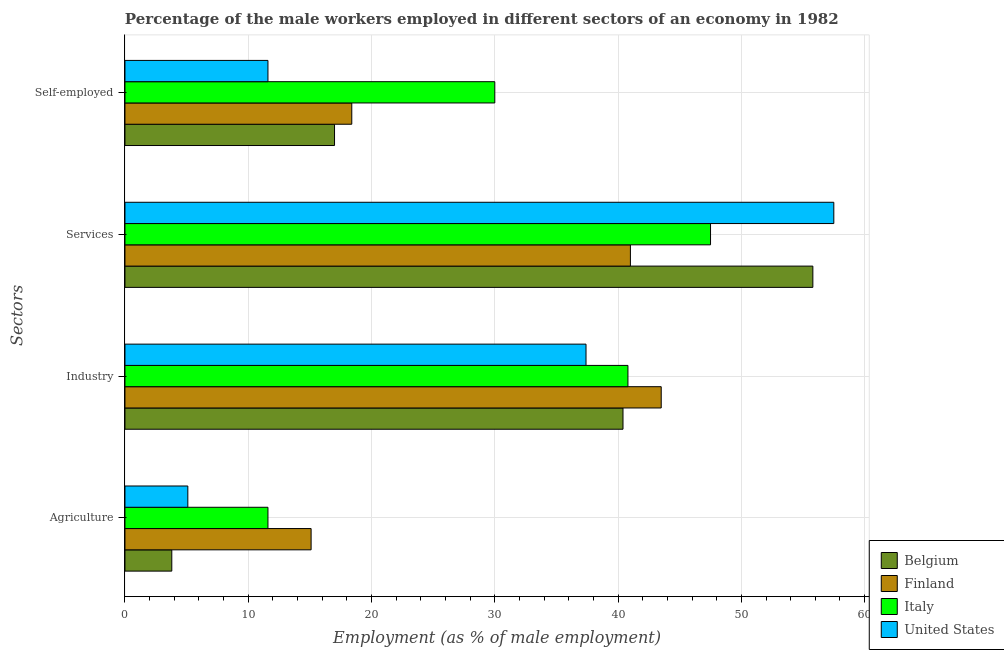How many groups of bars are there?
Offer a terse response. 4. Are the number of bars per tick equal to the number of legend labels?
Offer a terse response. Yes. Are the number of bars on each tick of the Y-axis equal?
Keep it short and to the point. Yes. What is the label of the 4th group of bars from the top?
Provide a short and direct response. Agriculture. What is the percentage of male workers in services in Italy?
Offer a terse response. 47.5. Across all countries, what is the maximum percentage of male workers in agriculture?
Offer a very short reply. 15.1. Across all countries, what is the minimum percentage of male workers in industry?
Your answer should be very brief. 37.4. What is the total percentage of self employed male workers in the graph?
Your answer should be very brief. 77. What is the difference between the percentage of male workers in industry in Finland and that in Italy?
Your answer should be very brief. 2.7. What is the difference between the percentage of male workers in agriculture in United States and the percentage of male workers in services in Finland?
Ensure brevity in your answer.  -35.9. What is the average percentage of male workers in services per country?
Your answer should be compact. 50.45. What is the difference between the percentage of male workers in services and percentage of male workers in agriculture in Finland?
Offer a terse response. 25.9. What is the ratio of the percentage of male workers in agriculture in Belgium to that in Finland?
Offer a terse response. 0.25. Is the difference between the percentage of male workers in agriculture in Finland and United States greater than the difference between the percentage of male workers in services in Finland and United States?
Your answer should be compact. Yes. What is the difference between the highest and the second highest percentage of male workers in industry?
Offer a very short reply. 2.7. What is the difference between the highest and the lowest percentage of male workers in agriculture?
Provide a succinct answer. 11.3. In how many countries, is the percentage of male workers in services greater than the average percentage of male workers in services taken over all countries?
Your answer should be compact. 2. Is the sum of the percentage of male workers in agriculture in Belgium and Finland greater than the maximum percentage of male workers in industry across all countries?
Ensure brevity in your answer.  No. Is it the case that in every country, the sum of the percentage of male workers in agriculture and percentage of male workers in services is greater than the sum of percentage of self employed male workers and percentage of male workers in industry?
Keep it short and to the point. No. Is it the case that in every country, the sum of the percentage of male workers in agriculture and percentage of male workers in industry is greater than the percentage of male workers in services?
Provide a short and direct response. No. How many bars are there?
Offer a very short reply. 16. How many legend labels are there?
Make the answer very short. 4. What is the title of the graph?
Keep it short and to the point. Percentage of the male workers employed in different sectors of an economy in 1982. Does "Kazakhstan" appear as one of the legend labels in the graph?
Your answer should be very brief. No. What is the label or title of the X-axis?
Give a very brief answer. Employment (as % of male employment). What is the label or title of the Y-axis?
Give a very brief answer. Sectors. What is the Employment (as % of male employment) of Belgium in Agriculture?
Make the answer very short. 3.8. What is the Employment (as % of male employment) of Finland in Agriculture?
Your response must be concise. 15.1. What is the Employment (as % of male employment) in Italy in Agriculture?
Provide a short and direct response. 11.6. What is the Employment (as % of male employment) of United States in Agriculture?
Ensure brevity in your answer.  5.1. What is the Employment (as % of male employment) in Belgium in Industry?
Your answer should be very brief. 40.4. What is the Employment (as % of male employment) of Finland in Industry?
Provide a short and direct response. 43.5. What is the Employment (as % of male employment) of Italy in Industry?
Your answer should be very brief. 40.8. What is the Employment (as % of male employment) in United States in Industry?
Give a very brief answer. 37.4. What is the Employment (as % of male employment) in Belgium in Services?
Give a very brief answer. 55.8. What is the Employment (as % of male employment) in Italy in Services?
Ensure brevity in your answer.  47.5. What is the Employment (as % of male employment) in United States in Services?
Keep it short and to the point. 57.5. What is the Employment (as % of male employment) of Belgium in Self-employed?
Your response must be concise. 17. What is the Employment (as % of male employment) of Finland in Self-employed?
Your response must be concise. 18.4. What is the Employment (as % of male employment) in Italy in Self-employed?
Provide a short and direct response. 30. What is the Employment (as % of male employment) of United States in Self-employed?
Offer a terse response. 11.6. Across all Sectors, what is the maximum Employment (as % of male employment) of Belgium?
Provide a short and direct response. 55.8. Across all Sectors, what is the maximum Employment (as % of male employment) of Finland?
Give a very brief answer. 43.5. Across all Sectors, what is the maximum Employment (as % of male employment) of Italy?
Give a very brief answer. 47.5. Across all Sectors, what is the maximum Employment (as % of male employment) in United States?
Your answer should be very brief. 57.5. Across all Sectors, what is the minimum Employment (as % of male employment) of Belgium?
Your answer should be compact. 3.8. Across all Sectors, what is the minimum Employment (as % of male employment) of Finland?
Give a very brief answer. 15.1. Across all Sectors, what is the minimum Employment (as % of male employment) of Italy?
Keep it short and to the point. 11.6. Across all Sectors, what is the minimum Employment (as % of male employment) in United States?
Your answer should be very brief. 5.1. What is the total Employment (as % of male employment) of Belgium in the graph?
Provide a succinct answer. 117. What is the total Employment (as % of male employment) in Finland in the graph?
Your answer should be very brief. 118. What is the total Employment (as % of male employment) in Italy in the graph?
Your response must be concise. 129.9. What is the total Employment (as % of male employment) of United States in the graph?
Offer a terse response. 111.6. What is the difference between the Employment (as % of male employment) of Belgium in Agriculture and that in Industry?
Provide a short and direct response. -36.6. What is the difference between the Employment (as % of male employment) of Finland in Agriculture and that in Industry?
Provide a succinct answer. -28.4. What is the difference between the Employment (as % of male employment) of Italy in Agriculture and that in Industry?
Provide a succinct answer. -29.2. What is the difference between the Employment (as % of male employment) of United States in Agriculture and that in Industry?
Give a very brief answer. -32.3. What is the difference between the Employment (as % of male employment) in Belgium in Agriculture and that in Services?
Give a very brief answer. -52. What is the difference between the Employment (as % of male employment) in Finland in Agriculture and that in Services?
Your answer should be compact. -25.9. What is the difference between the Employment (as % of male employment) of Italy in Agriculture and that in Services?
Provide a succinct answer. -35.9. What is the difference between the Employment (as % of male employment) in United States in Agriculture and that in Services?
Make the answer very short. -52.4. What is the difference between the Employment (as % of male employment) of Belgium in Agriculture and that in Self-employed?
Offer a terse response. -13.2. What is the difference between the Employment (as % of male employment) of Italy in Agriculture and that in Self-employed?
Your answer should be compact. -18.4. What is the difference between the Employment (as % of male employment) in Belgium in Industry and that in Services?
Make the answer very short. -15.4. What is the difference between the Employment (as % of male employment) of United States in Industry and that in Services?
Provide a succinct answer. -20.1. What is the difference between the Employment (as % of male employment) in Belgium in Industry and that in Self-employed?
Your answer should be compact. 23.4. What is the difference between the Employment (as % of male employment) in Finland in Industry and that in Self-employed?
Offer a very short reply. 25.1. What is the difference between the Employment (as % of male employment) of Italy in Industry and that in Self-employed?
Offer a very short reply. 10.8. What is the difference between the Employment (as % of male employment) of United States in Industry and that in Self-employed?
Your answer should be compact. 25.8. What is the difference between the Employment (as % of male employment) of Belgium in Services and that in Self-employed?
Your response must be concise. 38.8. What is the difference between the Employment (as % of male employment) of Finland in Services and that in Self-employed?
Give a very brief answer. 22.6. What is the difference between the Employment (as % of male employment) of United States in Services and that in Self-employed?
Your answer should be compact. 45.9. What is the difference between the Employment (as % of male employment) of Belgium in Agriculture and the Employment (as % of male employment) of Finland in Industry?
Give a very brief answer. -39.7. What is the difference between the Employment (as % of male employment) of Belgium in Agriculture and the Employment (as % of male employment) of Italy in Industry?
Keep it short and to the point. -37. What is the difference between the Employment (as % of male employment) in Belgium in Agriculture and the Employment (as % of male employment) in United States in Industry?
Keep it short and to the point. -33.6. What is the difference between the Employment (as % of male employment) of Finland in Agriculture and the Employment (as % of male employment) of Italy in Industry?
Offer a terse response. -25.7. What is the difference between the Employment (as % of male employment) of Finland in Agriculture and the Employment (as % of male employment) of United States in Industry?
Your answer should be compact. -22.3. What is the difference between the Employment (as % of male employment) of Italy in Agriculture and the Employment (as % of male employment) of United States in Industry?
Your response must be concise. -25.8. What is the difference between the Employment (as % of male employment) of Belgium in Agriculture and the Employment (as % of male employment) of Finland in Services?
Offer a terse response. -37.2. What is the difference between the Employment (as % of male employment) of Belgium in Agriculture and the Employment (as % of male employment) of Italy in Services?
Offer a terse response. -43.7. What is the difference between the Employment (as % of male employment) in Belgium in Agriculture and the Employment (as % of male employment) in United States in Services?
Give a very brief answer. -53.7. What is the difference between the Employment (as % of male employment) in Finland in Agriculture and the Employment (as % of male employment) in Italy in Services?
Provide a short and direct response. -32.4. What is the difference between the Employment (as % of male employment) in Finland in Agriculture and the Employment (as % of male employment) in United States in Services?
Your answer should be very brief. -42.4. What is the difference between the Employment (as % of male employment) in Italy in Agriculture and the Employment (as % of male employment) in United States in Services?
Ensure brevity in your answer.  -45.9. What is the difference between the Employment (as % of male employment) in Belgium in Agriculture and the Employment (as % of male employment) in Finland in Self-employed?
Offer a very short reply. -14.6. What is the difference between the Employment (as % of male employment) in Belgium in Agriculture and the Employment (as % of male employment) in Italy in Self-employed?
Your response must be concise. -26.2. What is the difference between the Employment (as % of male employment) in Belgium in Agriculture and the Employment (as % of male employment) in United States in Self-employed?
Your answer should be very brief. -7.8. What is the difference between the Employment (as % of male employment) of Finland in Agriculture and the Employment (as % of male employment) of Italy in Self-employed?
Give a very brief answer. -14.9. What is the difference between the Employment (as % of male employment) of Finland in Agriculture and the Employment (as % of male employment) of United States in Self-employed?
Give a very brief answer. 3.5. What is the difference between the Employment (as % of male employment) of Belgium in Industry and the Employment (as % of male employment) of Italy in Services?
Provide a short and direct response. -7.1. What is the difference between the Employment (as % of male employment) of Belgium in Industry and the Employment (as % of male employment) of United States in Services?
Offer a very short reply. -17.1. What is the difference between the Employment (as % of male employment) in Italy in Industry and the Employment (as % of male employment) in United States in Services?
Your answer should be compact. -16.7. What is the difference between the Employment (as % of male employment) of Belgium in Industry and the Employment (as % of male employment) of Finland in Self-employed?
Your response must be concise. 22. What is the difference between the Employment (as % of male employment) of Belgium in Industry and the Employment (as % of male employment) of Italy in Self-employed?
Your response must be concise. 10.4. What is the difference between the Employment (as % of male employment) in Belgium in Industry and the Employment (as % of male employment) in United States in Self-employed?
Your response must be concise. 28.8. What is the difference between the Employment (as % of male employment) of Finland in Industry and the Employment (as % of male employment) of United States in Self-employed?
Keep it short and to the point. 31.9. What is the difference between the Employment (as % of male employment) of Italy in Industry and the Employment (as % of male employment) of United States in Self-employed?
Your answer should be compact. 29.2. What is the difference between the Employment (as % of male employment) of Belgium in Services and the Employment (as % of male employment) of Finland in Self-employed?
Give a very brief answer. 37.4. What is the difference between the Employment (as % of male employment) in Belgium in Services and the Employment (as % of male employment) in Italy in Self-employed?
Offer a very short reply. 25.8. What is the difference between the Employment (as % of male employment) in Belgium in Services and the Employment (as % of male employment) in United States in Self-employed?
Your answer should be compact. 44.2. What is the difference between the Employment (as % of male employment) of Finland in Services and the Employment (as % of male employment) of United States in Self-employed?
Provide a succinct answer. 29.4. What is the difference between the Employment (as % of male employment) of Italy in Services and the Employment (as % of male employment) of United States in Self-employed?
Your answer should be compact. 35.9. What is the average Employment (as % of male employment) of Belgium per Sectors?
Make the answer very short. 29.25. What is the average Employment (as % of male employment) in Finland per Sectors?
Provide a succinct answer. 29.5. What is the average Employment (as % of male employment) in Italy per Sectors?
Offer a terse response. 32.48. What is the average Employment (as % of male employment) of United States per Sectors?
Give a very brief answer. 27.9. What is the difference between the Employment (as % of male employment) of Finland and Employment (as % of male employment) of Italy in Agriculture?
Offer a very short reply. 3.5. What is the difference between the Employment (as % of male employment) in Italy and Employment (as % of male employment) in United States in Agriculture?
Ensure brevity in your answer.  6.5. What is the difference between the Employment (as % of male employment) in Belgium and Employment (as % of male employment) in United States in Industry?
Your answer should be compact. 3. What is the difference between the Employment (as % of male employment) in Finland and Employment (as % of male employment) in Italy in Industry?
Make the answer very short. 2.7. What is the difference between the Employment (as % of male employment) in Finland and Employment (as % of male employment) in United States in Services?
Provide a short and direct response. -16.5. What is the difference between the Employment (as % of male employment) of Finland and Employment (as % of male employment) of Italy in Self-employed?
Your response must be concise. -11.6. What is the ratio of the Employment (as % of male employment) in Belgium in Agriculture to that in Industry?
Make the answer very short. 0.09. What is the ratio of the Employment (as % of male employment) of Finland in Agriculture to that in Industry?
Offer a terse response. 0.35. What is the ratio of the Employment (as % of male employment) of Italy in Agriculture to that in Industry?
Ensure brevity in your answer.  0.28. What is the ratio of the Employment (as % of male employment) in United States in Agriculture to that in Industry?
Your answer should be compact. 0.14. What is the ratio of the Employment (as % of male employment) of Belgium in Agriculture to that in Services?
Provide a short and direct response. 0.07. What is the ratio of the Employment (as % of male employment) in Finland in Agriculture to that in Services?
Keep it short and to the point. 0.37. What is the ratio of the Employment (as % of male employment) in Italy in Agriculture to that in Services?
Give a very brief answer. 0.24. What is the ratio of the Employment (as % of male employment) in United States in Agriculture to that in Services?
Offer a very short reply. 0.09. What is the ratio of the Employment (as % of male employment) of Belgium in Agriculture to that in Self-employed?
Your response must be concise. 0.22. What is the ratio of the Employment (as % of male employment) of Finland in Agriculture to that in Self-employed?
Offer a very short reply. 0.82. What is the ratio of the Employment (as % of male employment) of Italy in Agriculture to that in Self-employed?
Your answer should be very brief. 0.39. What is the ratio of the Employment (as % of male employment) of United States in Agriculture to that in Self-employed?
Give a very brief answer. 0.44. What is the ratio of the Employment (as % of male employment) of Belgium in Industry to that in Services?
Keep it short and to the point. 0.72. What is the ratio of the Employment (as % of male employment) in Finland in Industry to that in Services?
Your response must be concise. 1.06. What is the ratio of the Employment (as % of male employment) in Italy in Industry to that in Services?
Offer a very short reply. 0.86. What is the ratio of the Employment (as % of male employment) of United States in Industry to that in Services?
Provide a short and direct response. 0.65. What is the ratio of the Employment (as % of male employment) of Belgium in Industry to that in Self-employed?
Give a very brief answer. 2.38. What is the ratio of the Employment (as % of male employment) of Finland in Industry to that in Self-employed?
Provide a short and direct response. 2.36. What is the ratio of the Employment (as % of male employment) in Italy in Industry to that in Self-employed?
Your answer should be very brief. 1.36. What is the ratio of the Employment (as % of male employment) in United States in Industry to that in Self-employed?
Keep it short and to the point. 3.22. What is the ratio of the Employment (as % of male employment) of Belgium in Services to that in Self-employed?
Ensure brevity in your answer.  3.28. What is the ratio of the Employment (as % of male employment) in Finland in Services to that in Self-employed?
Make the answer very short. 2.23. What is the ratio of the Employment (as % of male employment) of Italy in Services to that in Self-employed?
Your answer should be compact. 1.58. What is the ratio of the Employment (as % of male employment) in United States in Services to that in Self-employed?
Provide a short and direct response. 4.96. What is the difference between the highest and the second highest Employment (as % of male employment) in Finland?
Offer a terse response. 2.5. What is the difference between the highest and the second highest Employment (as % of male employment) of United States?
Provide a short and direct response. 20.1. What is the difference between the highest and the lowest Employment (as % of male employment) of Finland?
Keep it short and to the point. 28.4. What is the difference between the highest and the lowest Employment (as % of male employment) of Italy?
Make the answer very short. 35.9. What is the difference between the highest and the lowest Employment (as % of male employment) of United States?
Ensure brevity in your answer.  52.4. 